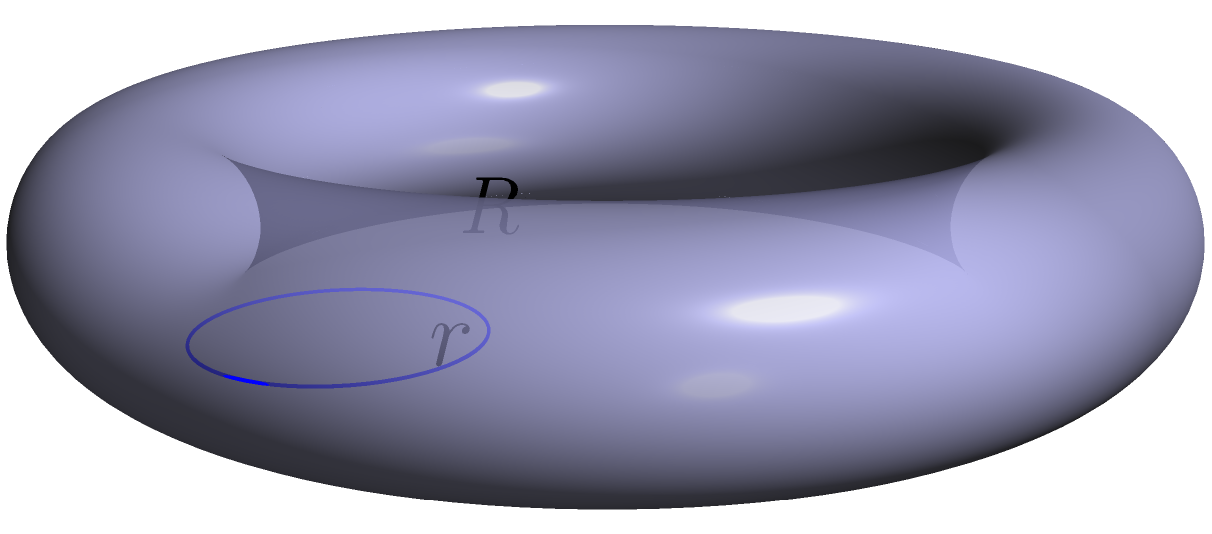In your latest track, you're spittin' bars about the shape of a donut, known in geometry as a torus. The inner radius (the hole) is $r = 0.5$ units, and the distance from the center of the hole to the center of the tube is $R = 2$ units. Calculate the surface area of this torus, rounding your answer to two decimal places. How many square units would cover this donut's surface? Let's break this down step-by-step:

1) The formula for the surface area of a torus is:
   
   $$A = 4\pi^2Rr$$

   Where $R$ is the distance from the center of the hole to the center of the tube, and $r$ is the radius of the tube.

2) We're given:
   $R = 2$ units
   $r = 0.5$ units

3) Let's substitute these values into our formula:

   $$A = 4\pi^2 \cdot 2 \cdot 0.5$$

4) Simplify:
   $$A = 4\pi^2$$

5) Calculate:
   $$A \approx 4 \cdot 9.8696 \approx 39.4784$$

6) Rounding to two decimal places:
   $$A \approx 39.48 \text{ square units}$$

So, the surface area of the torus is approximately 39.48 square units.
Answer: 39.48 square units 